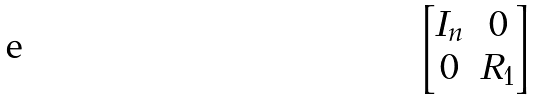<formula> <loc_0><loc_0><loc_500><loc_500>\begin{bmatrix} I _ { n } & 0 \\ 0 & R _ { 1 } \end{bmatrix}</formula> 